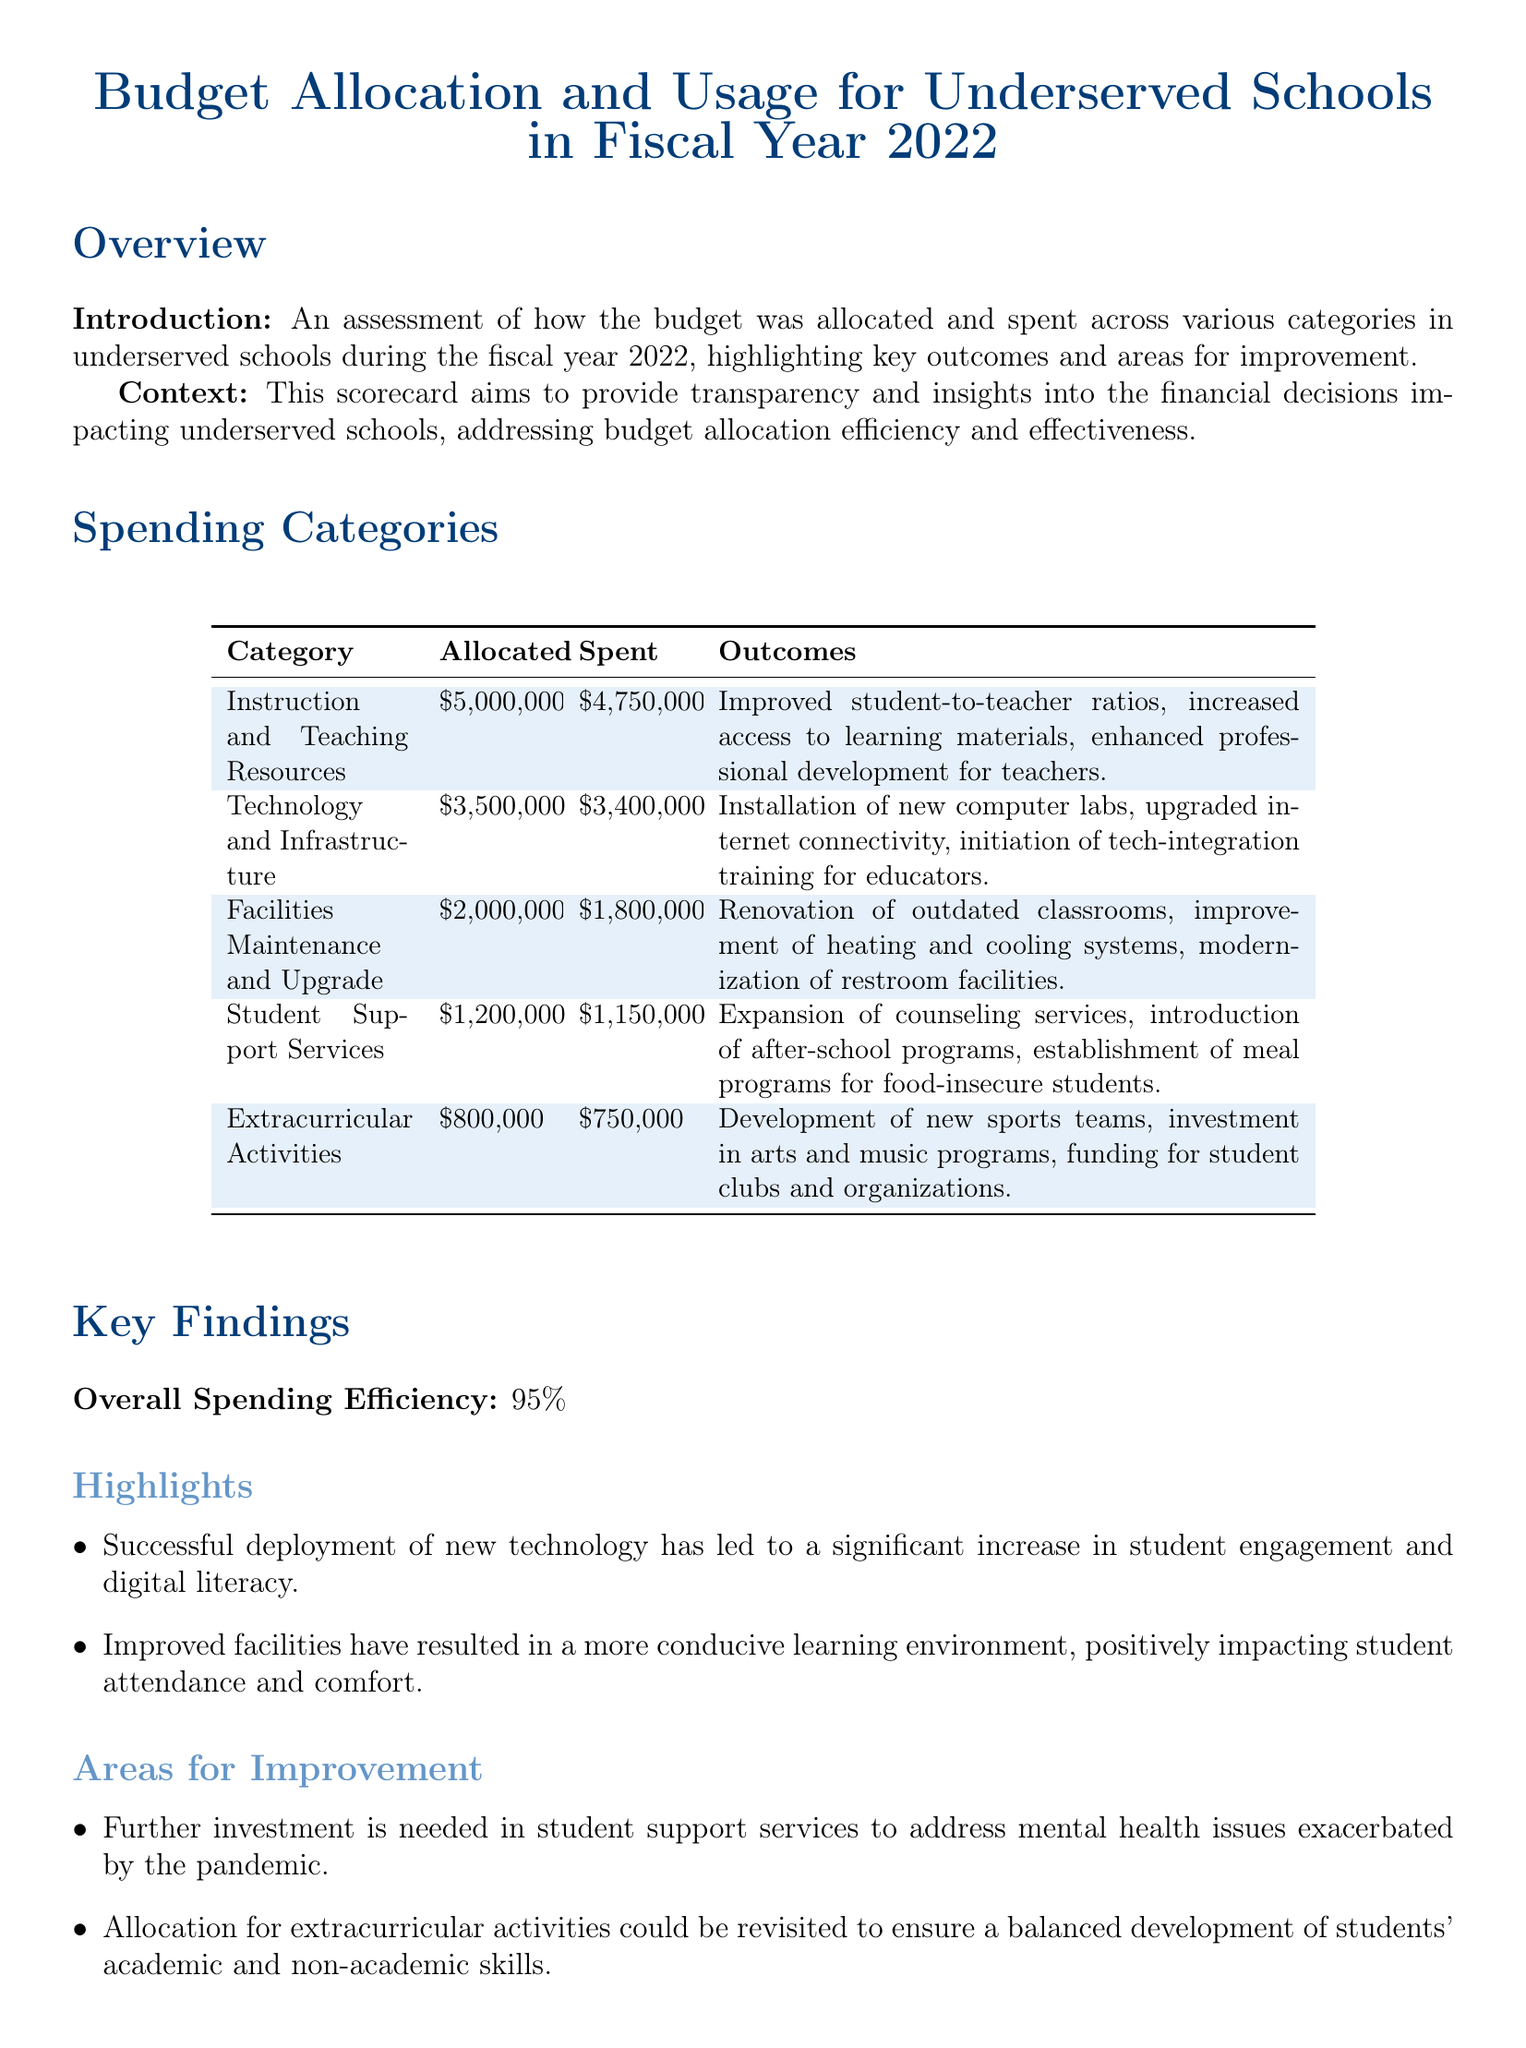What is the allocated budget for Instruction and Teaching Resources? The document specifies that the allocated budget for Instruction and Teaching Resources is clearly listed in the table.
Answer: $5,000,000 What percentage was the overall spending efficiency? The overall spending efficiency is explicitly stated in the Key Findings section.
Answer: 95% How much was spent on Facilities Maintenance and Upgrade? The document provides the amount spent on each category, including Facilities Maintenance and Upgrade, in the spending categories table.
Answer: $1,800,000 What improvement is noted in the outcomes for Technology and Infrastructure? The outcomes listed for this category provide information on specific improvements achieved through budget spending.
Answer: Installation of new computer labs Which category had the lowest spending after allocation? By comparing the spent amounts across all categories, we identify which one had the lowest spending.
Answer: Extracurricular Activities What area needs further investment according to the Areas for Improvement section? The document explicitly states areas that require further investment, as noted under Areas for Improvement.
Answer: Student support services What was initiated for educators under Technology and Infrastructure? The document highlights specific initiatives regarding technology integration in education that were financed.
Answer: Tech-integration training What is one notable success from improved facilities? The document lists positive outcomes related to improved facilities, specifically linked to student experience.
Answer: Increased student attendance 